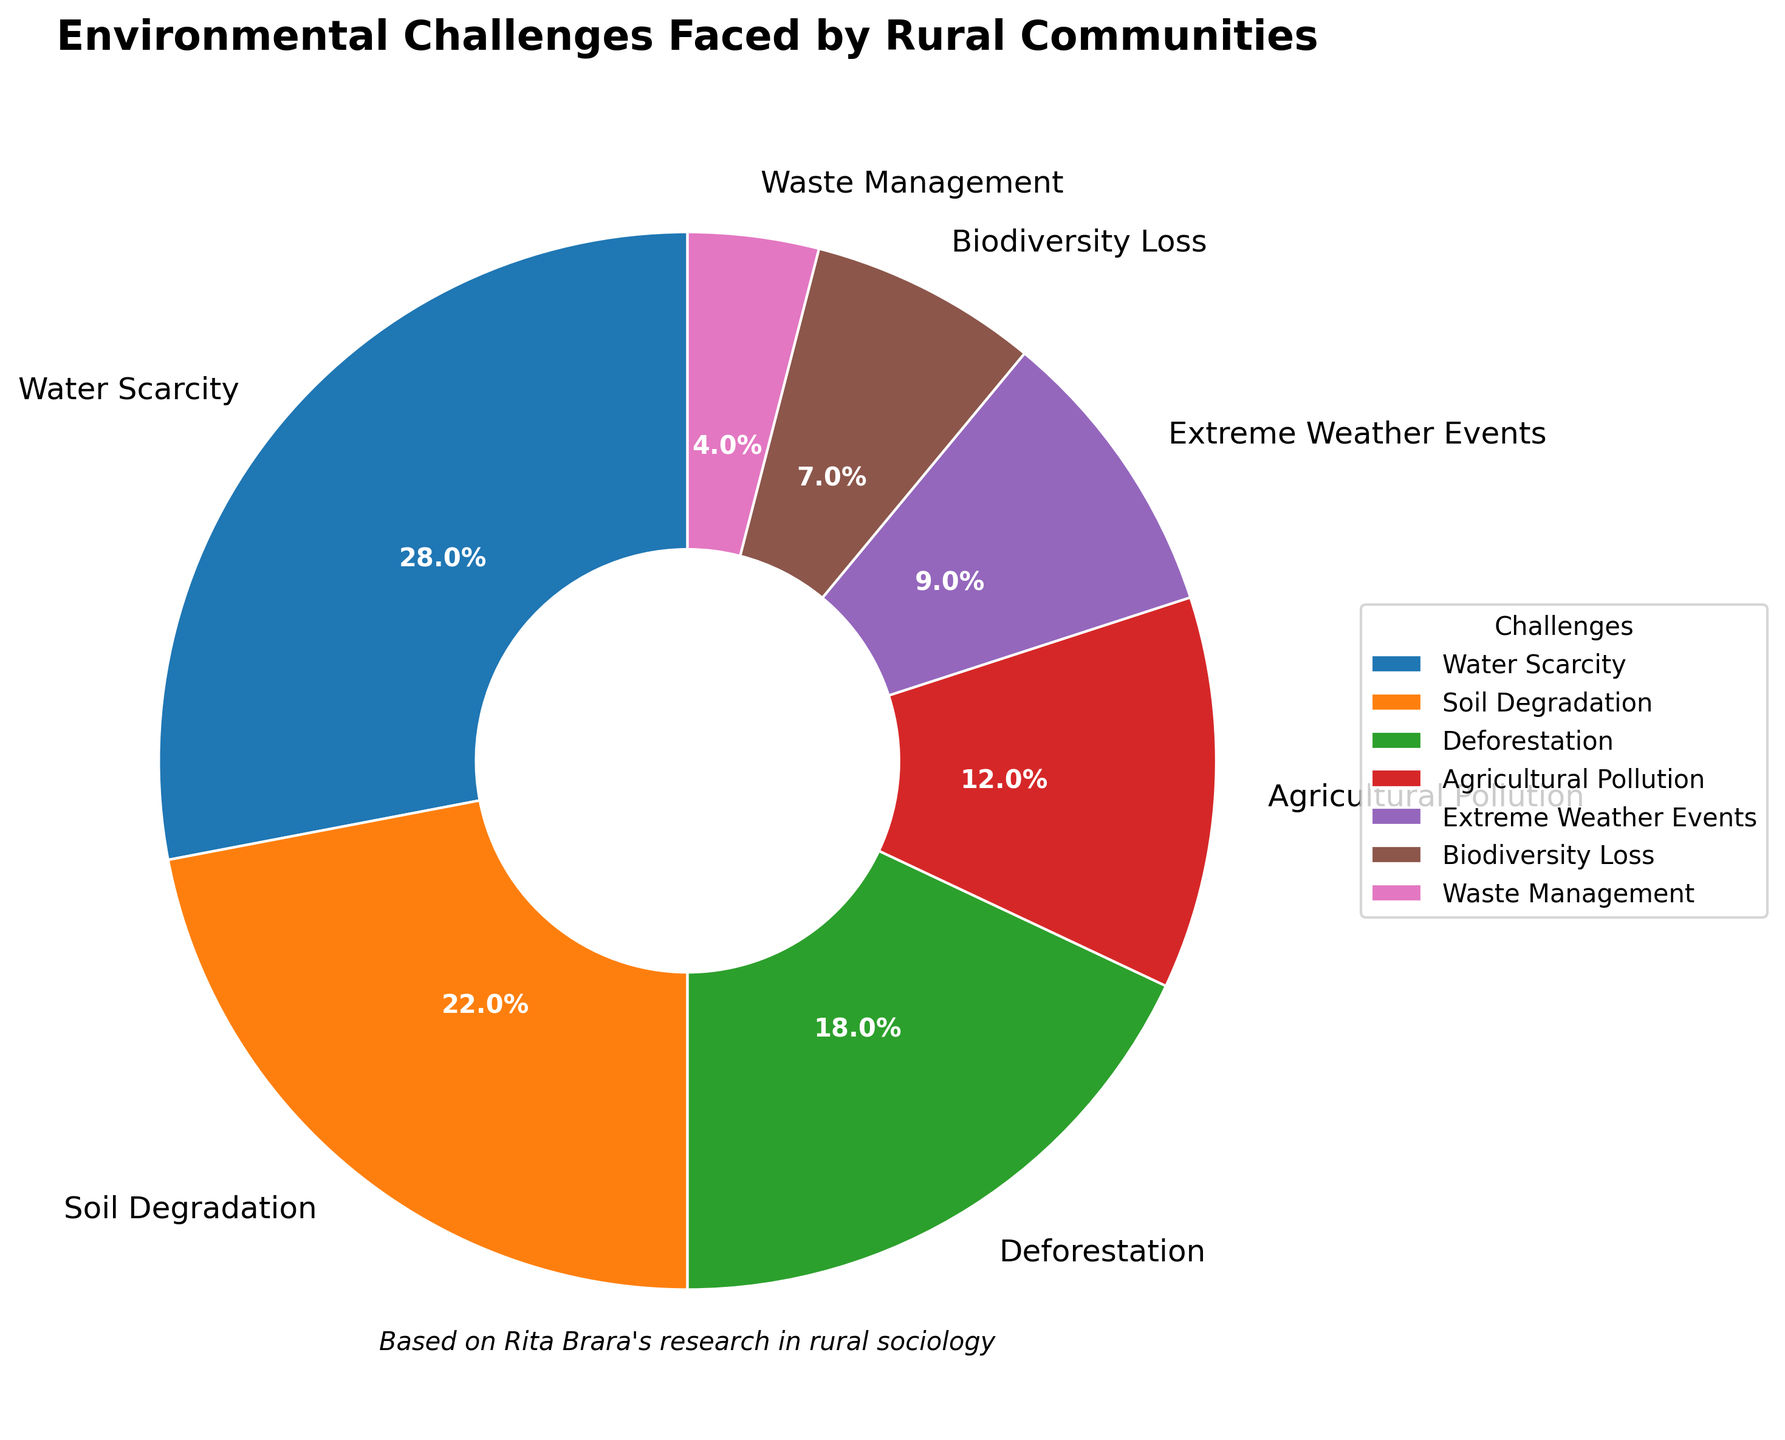What percentage of rural communities face water scarcity? To determine this, look at the portion of the pie chart labeled "Water Scarcity" and observe its corresponding percentage.
Answer: 28% Which environmental challenge has the smallest percentage? Find the segment of the pie chart that occupies the smallest area and read the label to identify the challenge with the lowest percentage.
Answer: Waste Management How much larger is the percentage of communities facing soil degradation compared to those facing extreme weather events? Subtract the percentage of extreme weather events from the percentage of soil degradation: 22% - 9% = 13%.
Answer: 13% What is the combined percentage of rural communities facing deforestation and agricultural pollution? Add the percentages of deforestation and agricultural pollution: 18% + 12% = 30%.
Answer: 30% Which environmental challenge occupies the second largest portion of the pie chart? Identify the segment with the second largest area after water scarcity and read its label.
Answer: Soil Degradation If you sum up the percentages of biodiversity loss, waste management, and extreme weather events, what do you get? Add the percentages of biodiversity loss, waste management, and extreme weather events: 7% + 4% + 9% = 20%.
Answer: 20% How does the portion representing biodiversity loss visually compare to the portion representing agricultural pollution? Visually compare the segments of the pie chart corresponding to biodiversity loss and agricultural pollution, noting that the segment for agricultural pollution is larger.
Answer: Agricultural Pollution is larger What is the difference between the percentages of communities facing water scarcity and deforestation? Subtract the percentage of deforestation from the percentage of water scarcity: 28% - 18% = 10%.
Answer: 10% Which color is used to represent soil degradation, and what is its percentage? Identify the color associated with the "Soil Degradation" segment on the pie chart and note the percentage indicated.
Answer: Orange, 22% Comparing soil degradation and biodiversity loss, which one has a higher percentage and by how much? Note the percentages of soil degradation and biodiversity loss, then subtract the smaller percentage (biodiversity loss) from the larger one (soil degradation): 22% - 7% = 15%.
Answer: Soil Degradation by 15% 